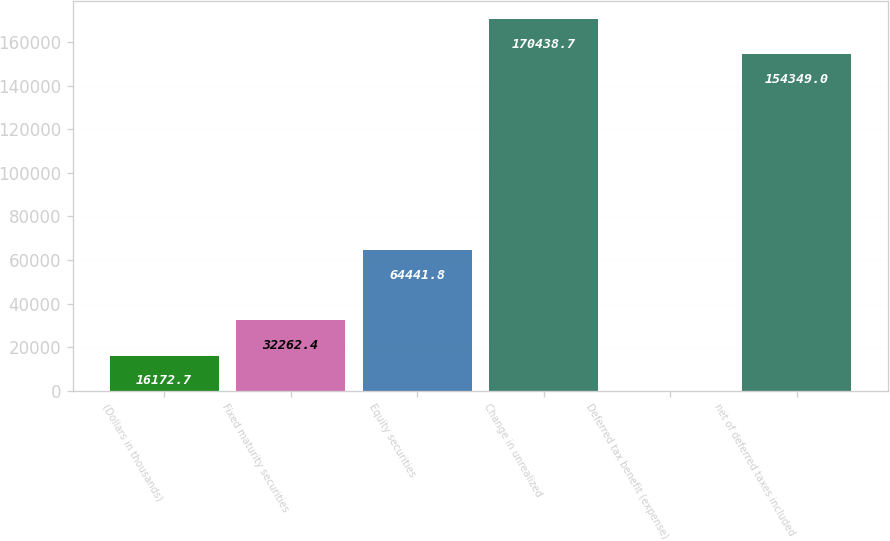Convert chart. <chart><loc_0><loc_0><loc_500><loc_500><bar_chart><fcel>(Dollars in thousands)<fcel>Fixed maturity securities<fcel>Equity securities<fcel>Change in unrealized<fcel>Deferred tax benefit (expense)<fcel>net of deferred taxes included<nl><fcel>16172.7<fcel>32262.4<fcel>64441.8<fcel>170439<fcel>83<fcel>154349<nl></chart> 